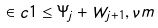<formula> <loc_0><loc_0><loc_500><loc_500>\in c 1 \leq \Psi _ { j } + W _ { j + 1 } , \nu m</formula> 